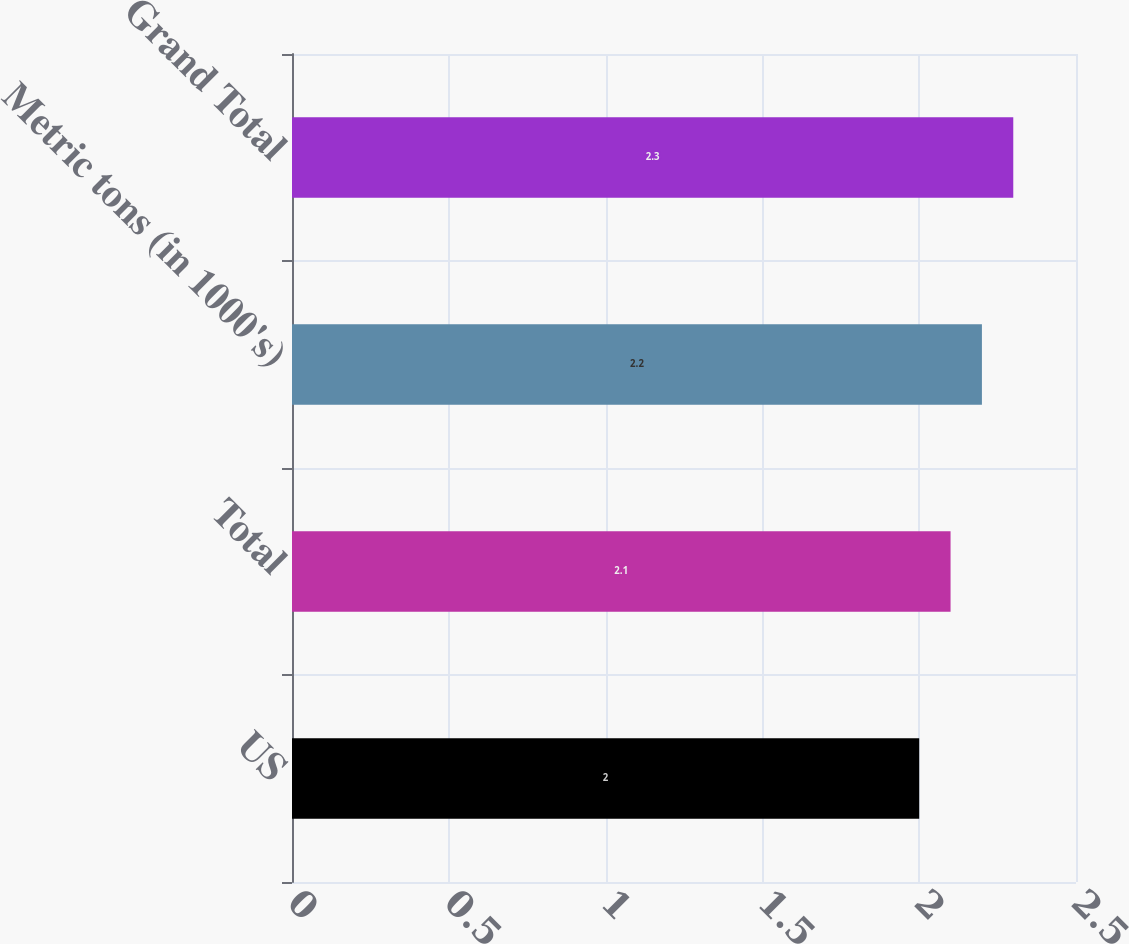Convert chart to OTSL. <chart><loc_0><loc_0><loc_500><loc_500><bar_chart><fcel>US<fcel>Total<fcel>Metric tons (in 1000's)<fcel>Grand Total<nl><fcel>2<fcel>2.1<fcel>2.2<fcel>2.3<nl></chart> 